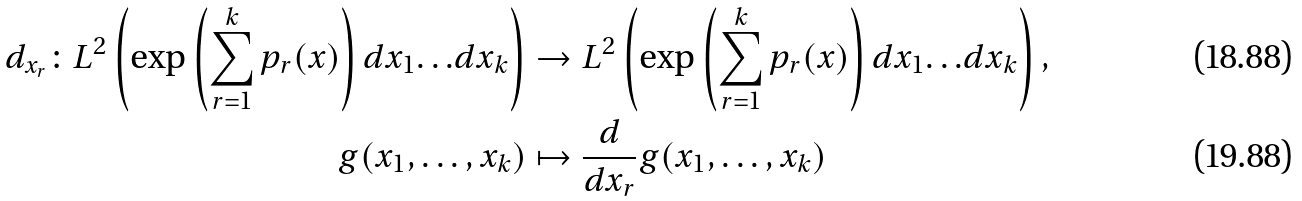Convert formula to latex. <formula><loc_0><loc_0><loc_500><loc_500>d _ { x _ { r } } \colon L ^ { 2 } \left ( \exp \left ( \sum _ { r = 1 } ^ { k } p _ { r } ( x ) \right ) d x _ { 1 } { \dots } d x _ { k } \right ) & \rightarrow { L } ^ { 2 } \left ( \exp \left ( \sum _ { r = 1 } ^ { k } p _ { r } ( x ) \right ) d x _ { 1 } { \dots } d x _ { k } \right ) , \\ g ( x _ { 1 } , \dots , x _ { k } ) & \mapsto \frac { d } { d x _ { r } } g ( x _ { 1 } , \dots , x _ { k } )</formula> 